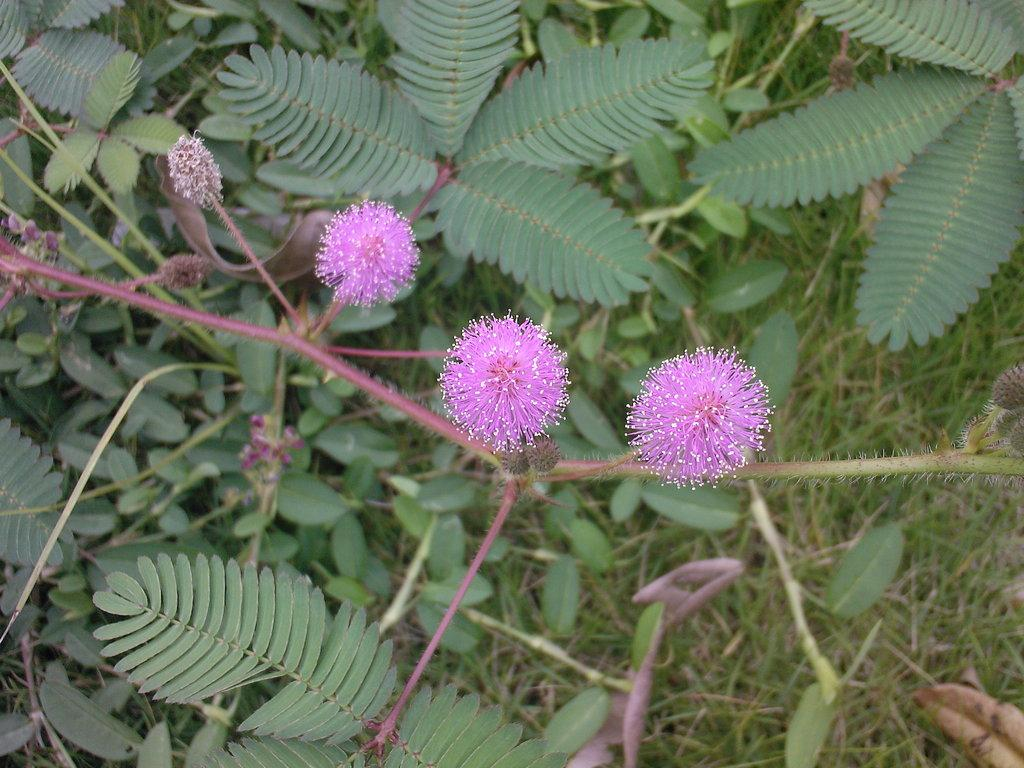What type of flora can be seen in the image? There are flowers in the image. What color are the flowers? A: The flowers are purple in color. What other types of plants are present in the image? There are plants with leaves in the image. What type of vegetation is visible in the image besides the flowers and plants? There is grass visible in the image. How many rabbits can be seen hopping through the flowers in the image? There are no rabbits present in the image; it only features flowers, plants, and grass. 